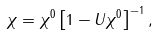Convert formula to latex. <formula><loc_0><loc_0><loc_500><loc_500>\chi = \chi ^ { 0 } \left [ 1 - U \chi ^ { 0 } \right ] ^ { - 1 } ,</formula> 